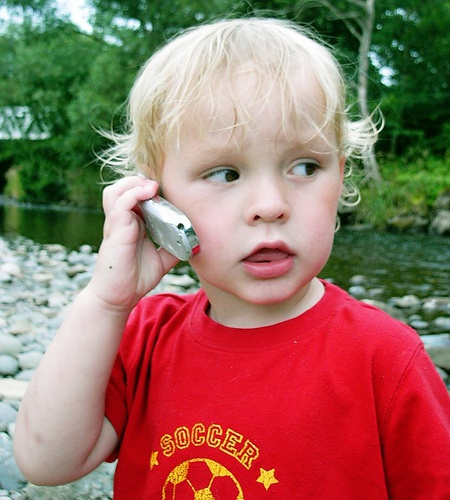Describe the objects in this image and their specific colors. I can see people in teal, brown, lightgray, and darkgray tones and cell phone in teal, darkgray, white, gray, and brown tones in this image. 